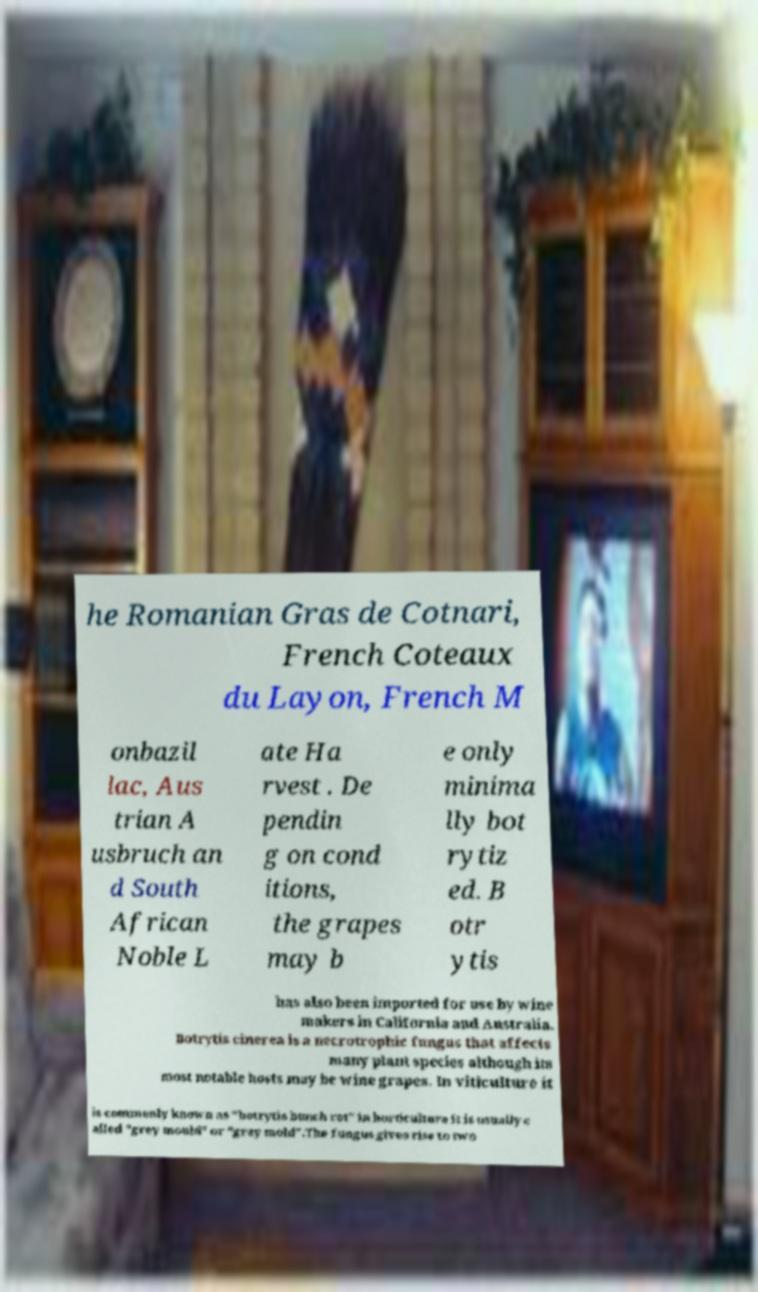Please read and relay the text visible in this image. What does it say? he Romanian Gras de Cotnari, French Coteaux du Layon, French M onbazil lac, Aus trian A usbruch an d South African Noble L ate Ha rvest . De pendin g on cond itions, the grapes may b e only minima lly bot rytiz ed. B otr ytis has also been imported for use by wine makers in California and Australia. Botrytis cinerea is a necrotrophic fungus that affects many plant species although its most notable hosts may be wine grapes. In viticulture it is commonly known as "botrytis bunch rot" in horticulture it is usually c alled "grey mould" or "gray mold".The fungus gives rise to two 